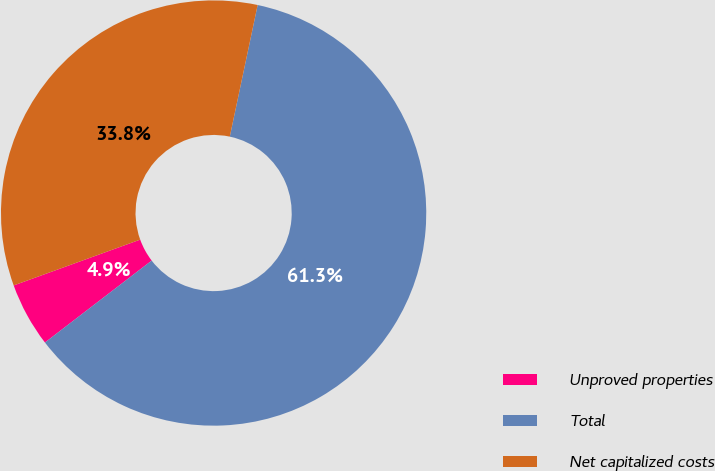Convert chart. <chart><loc_0><loc_0><loc_500><loc_500><pie_chart><fcel>Unproved properties<fcel>Total<fcel>Net capitalized costs<nl><fcel>4.89%<fcel>61.26%<fcel>33.85%<nl></chart> 